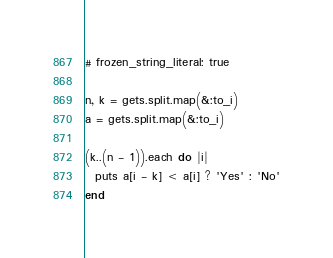Convert code to text. <code><loc_0><loc_0><loc_500><loc_500><_Ruby_># frozen_string_literal: true

n, k = gets.split.map(&:to_i)
a = gets.split.map(&:to_i)

(k..(n - 1)).each do |i|
  puts a[i - k] < a[i] ? 'Yes' : 'No'
end
</code> 